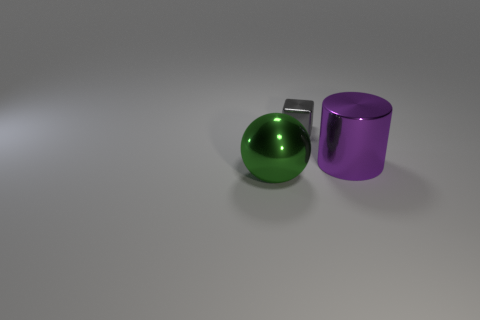There is a block that is made of the same material as the cylinder; what is its size?
Keep it short and to the point. Small. There is a shiny object in front of the large shiny thing to the right of the big object to the left of the tiny gray metallic thing; how big is it?
Ensure brevity in your answer.  Large. What is the color of the big object that is left of the big purple shiny cylinder?
Keep it short and to the point. Green. Is the number of objects that are behind the green metallic thing greater than the number of big blocks?
Keep it short and to the point. Yes. There is a metal thing left of the tiny gray thing; is it the same shape as the small gray object?
Keep it short and to the point. No. How many gray objects are either tiny spheres or small things?
Keep it short and to the point. 1. Is the number of purple metal cylinders greater than the number of large brown blocks?
Your answer should be compact. Yes. There is another metallic thing that is the same size as the green metal object; what is its color?
Your answer should be compact. Purple. What number of cylinders are either large blue objects or green metallic objects?
Your answer should be compact. 0. How many metallic spheres are the same size as the gray shiny object?
Your answer should be compact. 0. 